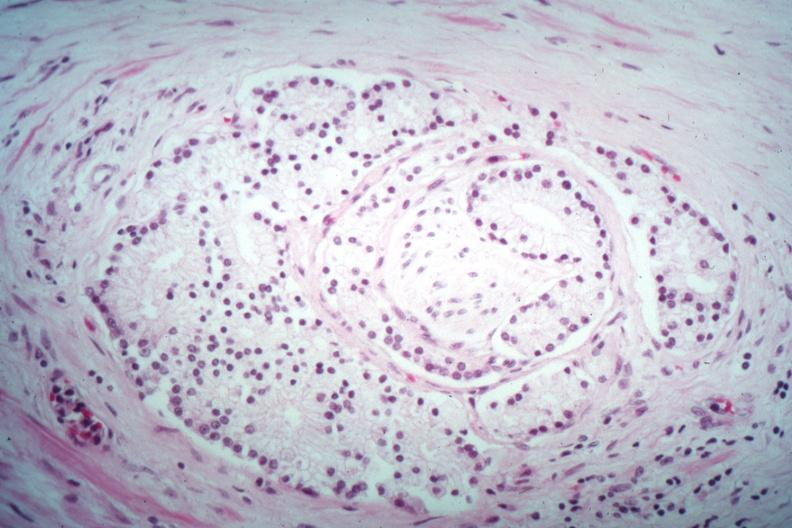how does this image show nice perineural invasion?
Answer the question using a single word or phrase. By well differentiated adenocarcinoma 